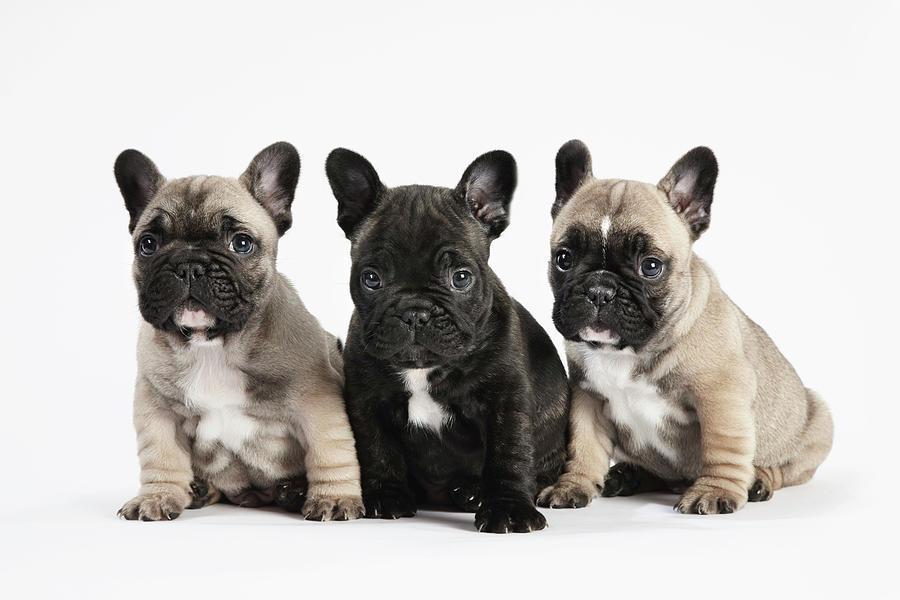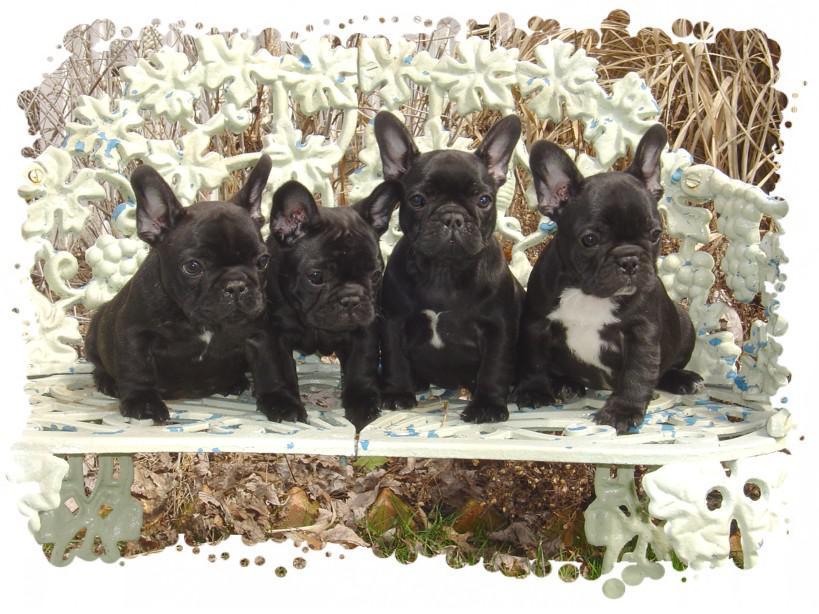The first image is the image on the left, the second image is the image on the right. Given the left and right images, does the statement "There are seven dogs." hold true? Answer yes or no. Yes. 